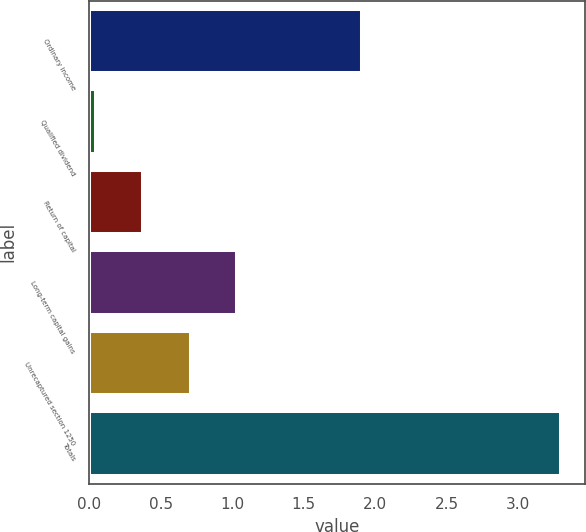<chart> <loc_0><loc_0><loc_500><loc_500><bar_chart><fcel>Ordinary income<fcel>Qualified dividend<fcel>Return of capital<fcel>Long-term capital gains<fcel>Unrecaptured section 1250<fcel>Totals<nl><fcel>1.91<fcel>0.05<fcel>0.38<fcel>1.03<fcel>0.71<fcel>3.3<nl></chart> 